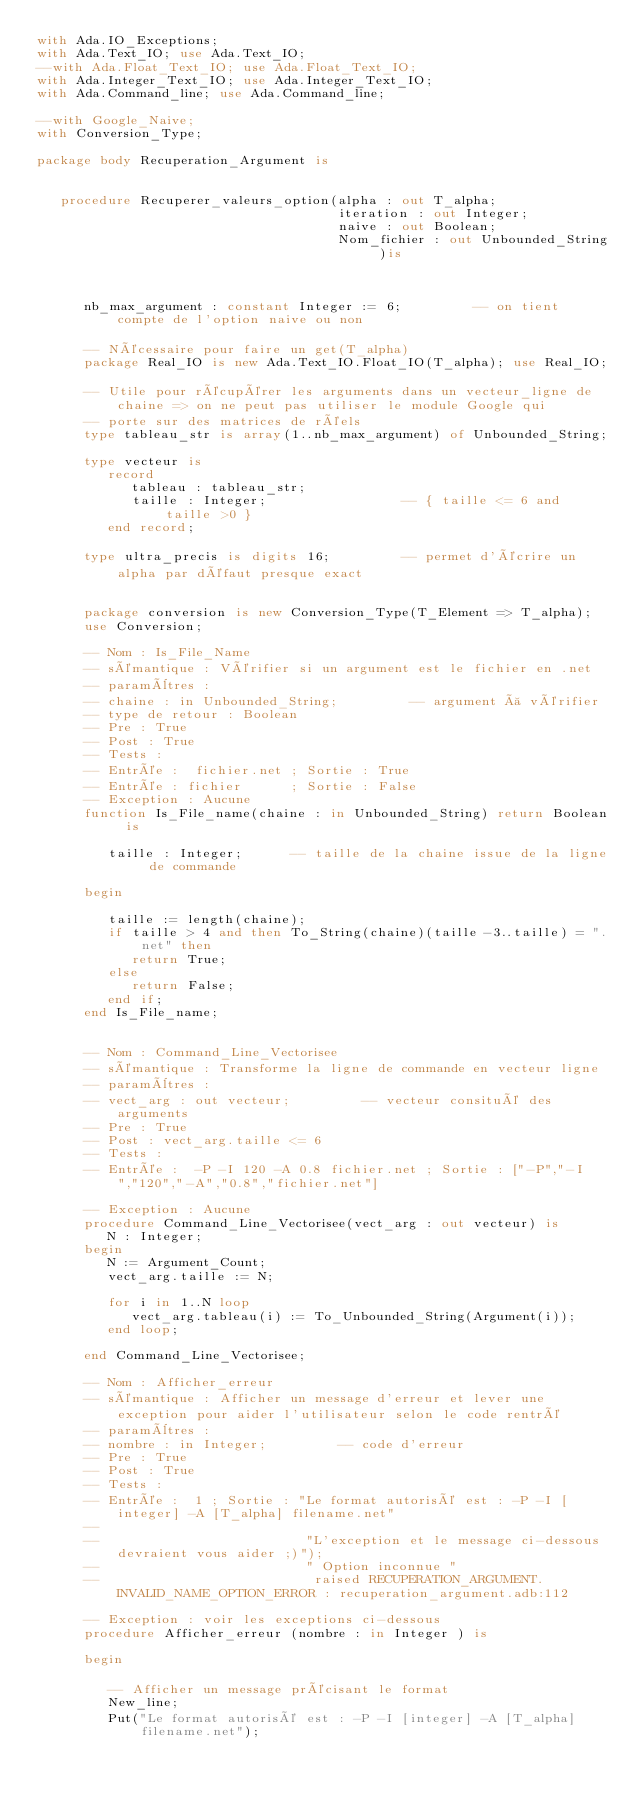Convert code to text. <code><loc_0><loc_0><loc_500><loc_500><_Ada_>with Ada.IO_Exceptions;
with Ada.Text_IO; use Ada.Text_IO;
--with Ada.Float_Text_IO; use Ada.Float_Text_IO;
with Ada.Integer_Text_IO; use Ada.Integer_Text_IO;
with Ada.Command_line; use Ada.Command_line;

--with Google_Naive;
with Conversion_Type;

package body Recuperation_Argument is


   procedure Recuperer_valeurs_option(alpha : out T_alpha;
                                      iteration : out Integer;
                                      naive : out Boolean;
                                      Nom_fichier : out Unbounded_String )is



      nb_max_argument : constant Integer := 6;         -- on tient compte de l'option naive ou non

      -- Nécessaire pour faire un get(T_alpha)
      package Real_IO is new Ada.Text_IO.Float_IO(T_alpha); use Real_IO;

      -- Utile pour récupérer les arguments dans un vecteur_ligne de chaine => on ne peut pas utiliser le module Google qui
      -- porte sur des matrices de réels
      type tableau_str is array(1..nb_max_argument) of Unbounded_String;

      type vecteur is
         record
            tableau : tableau_str;
            taille : Integer;                 -- { taille <= 6 and taille >0 }
         end record;

      type ultra_precis is digits 16;         -- permet d'écrire un alpha par défaut presque exact


      package conversion is new Conversion_Type(T_Element => T_alpha);
      use Conversion;

      -- Nom : Is_File_Name
      -- sémantique : Vérifier si un argument est le fichier en .net
      -- paramètres :
      -- chaine : in Unbounded_String;         -- argument à vérifier
      -- type de retour : Boolean
      -- Pre : True
      -- Post : True
      -- Tests :
      -- Entrée :  fichier.net ; Sortie : True
      -- Entrée : fichier      ; Sortie : False
      -- Exception : Aucune
      function Is_File_name(chaine : in Unbounded_String) return Boolean is

         taille : Integer;      -- taille de la chaine issue de la ligne de commande

      begin

         taille := length(chaine);
         if taille > 4 and then To_String(chaine)(taille-3..taille) = ".net" then
            return True;
         else
            return False;
         end if;
      end Is_File_name;


      -- Nom : Command_Line_Vectorisee
      -- sémantique : Transforme la ligne de commande en vecteur ligne
      -- paramètres :
      -- vect_arg : out vecteur;         -- vecteur consitué des arguments
      -- Pre : True
      -- Post : vect_arg.taille <= 6
      -- Tests :
      -- Entrée :  -P -I 120 -A 0.8 fichier.net ; Sortie : ["-P","-I","120","-A","0.8","fichier.net"]

      -- Exception : Aucune
      procedure Command_Line_Vectorisee(vect_arg : out vecteur) is
         N : Integer;
      begin
         N := Argument_Count;
         vect_arg.taille := N;

         for i in 1..N loop
            vect_arg.tableau(i) := To_Unbounded_String(Argument(i));
         end loop;

      end Command_Line_Vectorisee;

      -- Nom : Afficher_erreur
      -- sémantique : Afficher un message d'erreur et lever une exception pour aider l'utilisateur selon le code rentré
      -- paramètres :
      -- nombre : in Integer;         -- code d'erreur
      -- Pre : True
      -- Post : True
      -- Tests :
      -- Entrée :  1 ; Sortie : "Le format autorisé est : -P -I [integer] -A [T_alpha] filename.net"
      --
      --                          "L'exception et le message ci-dessous devraient vous aider ;)");
      --                          " Option inconnue "
      --                           raised RECUPERATION_ARGUMENT.INVALID_NAME_OPTION_ERROR : recuperation_argument.adb:112

      -- Exception : voir les exceptions ci-dessous
      procedure Afficher_erreur (nombre : in Integer ) is

      begin

         -- Afficher un message précisant le format
         New_line;
         Put("Le format autorisé est : -P -I [integer] -A [T_alpha] filename.net");</code> 